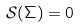<formula> <loc_0><loc_0><loc_500><loc_500>\mathcal { S } ( \Sigma ) = 0</formula> 